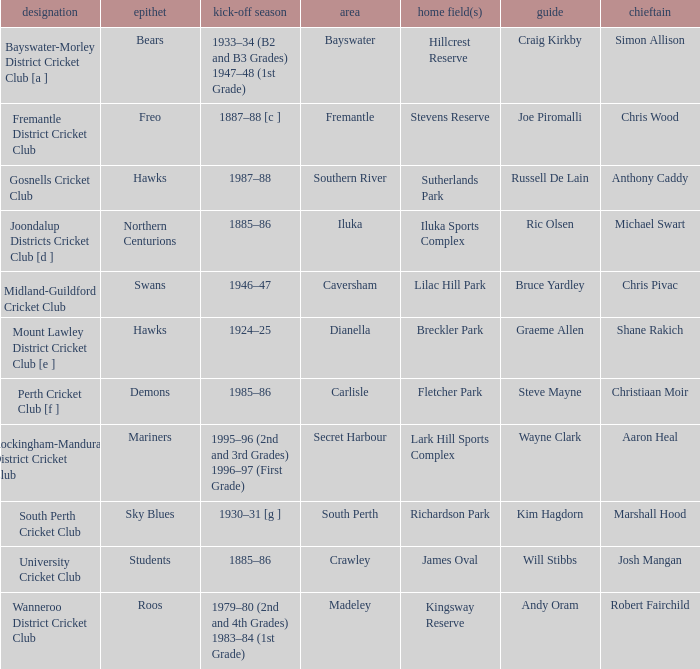With the nickname the swans, what is the home ground? Lilac Hill Park. 